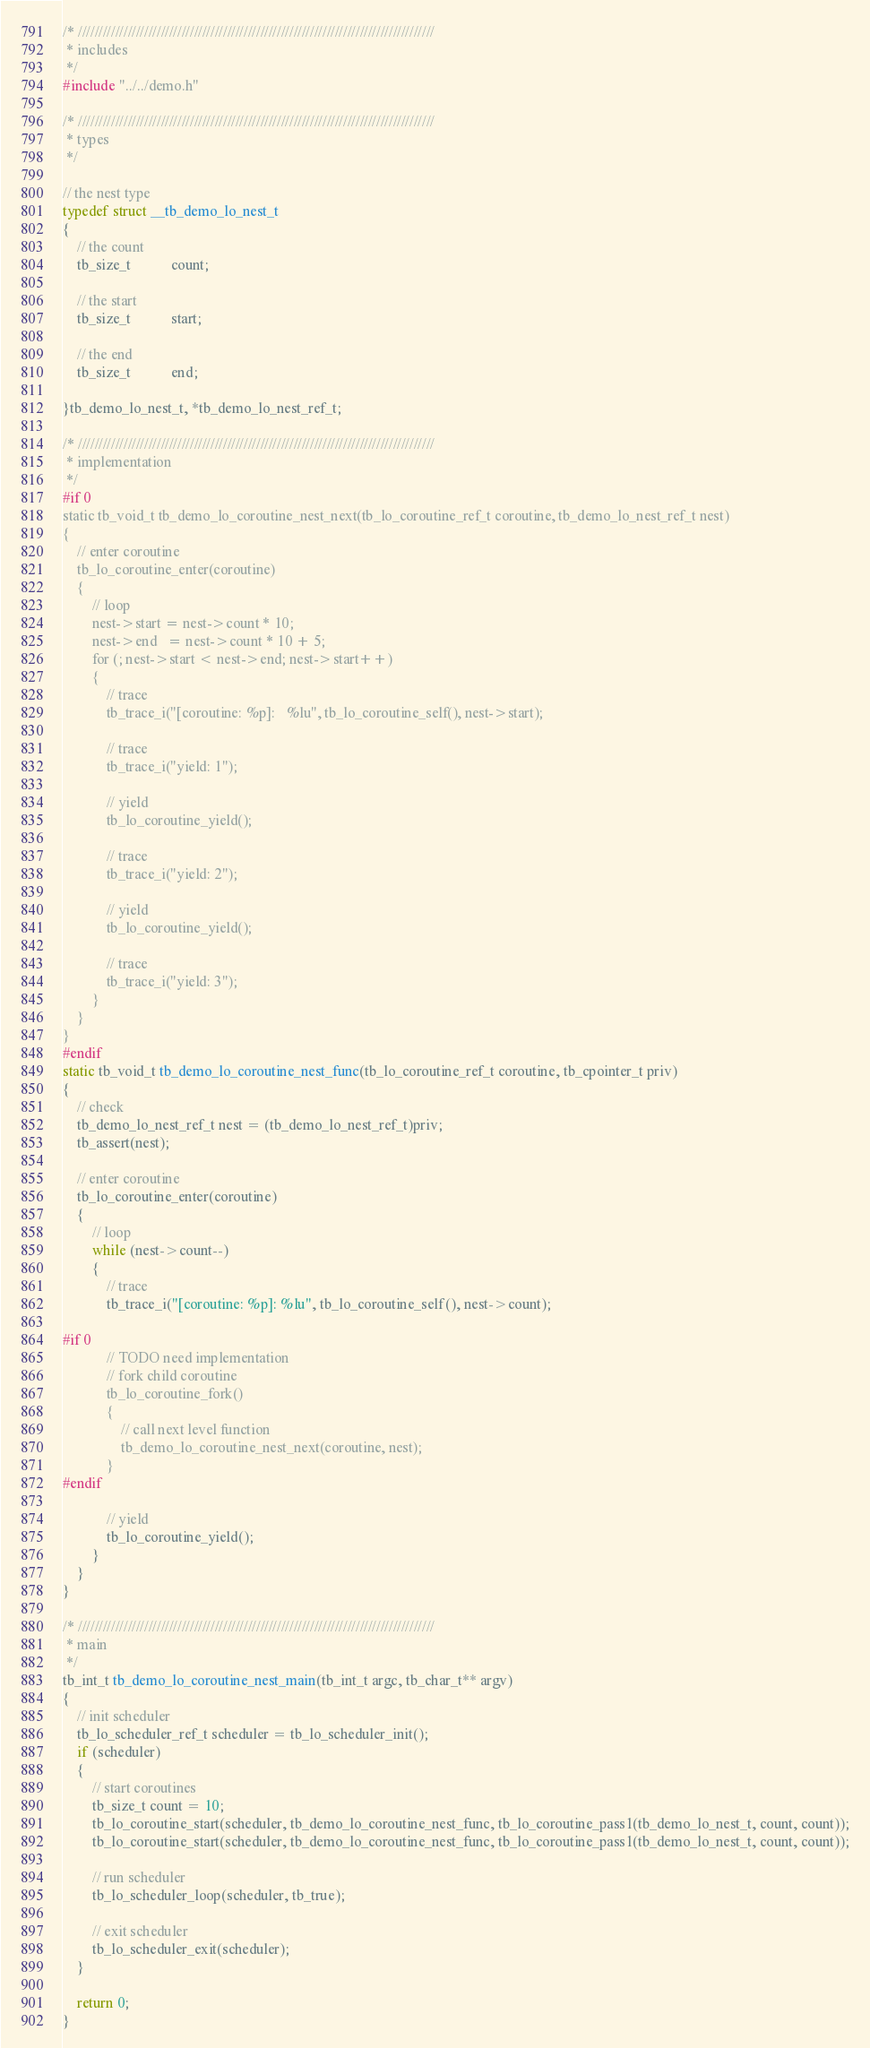Convert code to text. <code><loc_0><loc_0><loc_500><loc_500><_C_>/* //////////////////////////////////////////////////////////////////////////////////////
 * includes
 */
#include "../../demo.h"

/* //////////////////////////////////////////////////////////////////////////////////////
 * types
 */

// the nest type
typedef struct __tb_demo_lo_nest_t
{
    // the count
    tb_size_t           count;

    // the start
    tb_size_t           start;

    // the end
    tb_size_t           end;

}tb_demo_lo_nest_t, *tb_demo_lo_nest_ref_t;

/* //////////////////////////////////////////////////////////////////////////////////////
 * implementation
 */
#if 0
static tb_void_t tb_demo_lo_coroutine_nest_next(tb_lo_coroutine_ref_t coroutine, tb_demo_lo_nest_ref_t nest)
{
    // enter coroutine
    tb_lo_coroutine_enter(coroutine)
    {
        // loop
        nest->start = nest->count * 10;
        nest->end   = nest->count * 10 + 5;
        for (; nest->start < nest->end; nest->start++)
        {
            // trace
            tb_trace_i("[coroutine: %p]:   %lu", tb_lo_coroutine_self(), nest->start);

            // trace
            tb_trace_i("yield: 1");

            // yield
            tb_lo_coroutine_yield();

            // trace
            tb_trace_i("yield: 2");

            // yield
            tb_lo_coroutine_yield();

            // trace
            tb_trace_i("yield: 3");
        }
    }
}
#endif
static tb_void_t tb_demo_lo_coroutine_nest_func(tb_lo_coroutine_ref_t coroutine, tb_cpointer_t priv)
{
    // check
    tb_demo_lo_nest_ref_t nest = (tb_demo_lo_nest_ref_t)priv;
    tb_assert(nest);

    // enter coroutine
    tb_lo_coroutine_enter(coroutine)
    {
        // loop
        while (nest->count--)
        {
            // trace
            tb_trace_i("[coroutine: %p]: %lu", tb_lo_coroutine_self(), nest->count);

#if 0
            // TODO need implementation
            // fork child coroutine
            tb_lo_coroutine_fork()
            {
                // call next level function
                tb_demo_lo_coroutine_nest_next(coroutine, nest);
            }
#endif

            // yield
            tb_lo_coroutine_yield();
        }
    }
}

/* //////////////////////////////////////////////////////////////////////////////////////
 * main
 */
tb_int_t tb_demo_lo_coroutine_nest_main(tb_int_t argc, tb_char_t** argv)
{
    // init scheduler
    tb_lo_scheduler_ref_t scheduler = tb_lo_scheduler_init();
    if (scheduler)
    {
        // start coroutines
        tb_size_t count = 10;
        tb_lo_coroutine_start(scheduler, tb_demo_lo_coroutine_nest_func, tb_lo_coroutine_pass1(tb_demo_lo_nest_t, count, count));
        tb_lo_coroutine_start(scheduler, tb_demo_lo_coroutine_nest_func, tb_lo_coroutine_pass1(tb_demo_lo_nest_t, count, count));

        // run scheduler
        tb_lo_scheduler_loop(scheduler, tb_true);

        // exit scheduler
        tb_lo_scheduler_exit(scheduler);
    }

    return 0;
}
</code> 